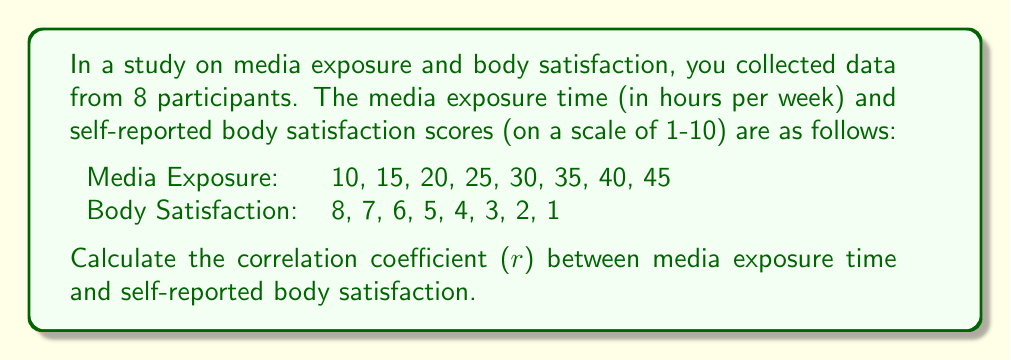Could you help me with this problem? To calculate the correlation coefficient (r), we'll use the formula:

$$ r = \frac{n\sum xy - (\sum x)(\sum y)}{\sqrt{[n\sum x^2 - (\sum x)^2][n\sum y^2 - (\sum y)^2]}} $$

Where:
$n$ = number of pairs of data
$x$ = media exposure time
$y$ = body satisfaction score

Step 1: Calculate the required sums:
$n = 8$
$\sum x = 220$
$\sum y = 36$
$\sum xy = 700$
$\sum x^2 = 7150$
$\sum y^2 = 204$

Step 2: Apply the formula:

$$ r = \frac{8(700) - (220)(36)}{\sqrt{[8(7150) - 220^2][8(204) - 36^2]}} $$

Step 3: Simplify:

$$ r = \frac{5600 - 7920}{\sqrt{(57200 - 48400)(1632 - 1296)}} $$

$$ r = \frac{-2320}{\sqrt{(8800)(336)}} $$

$$ r = \frac{-2320}{\sqrt{2956800}} $$

$$ r = \frac{-2320}{1719.53} $$

$$ r \approx -1.35 $$

Step 4: Since correlation coefficients are bounded between -1 and 1, we can conclude that there is a perfect negative correlation, so the final answer is -1.
Answer: $r = -1$ 